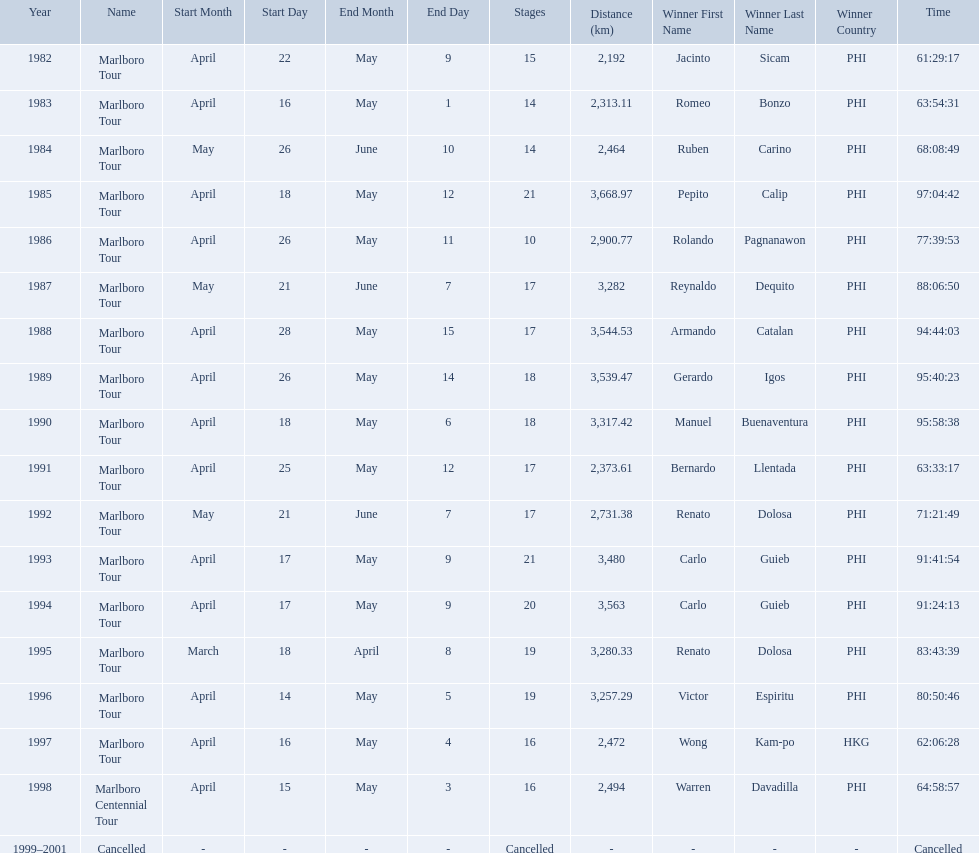What were the tour names during le tour de filipinas? Marlboro Tour, Marlboro Tour, Marlboro Tour, Marlboro Tour, Marlboro Tour, Marlboro Tour, Marlboro Tour, Marlboro Tour, Marlboro Tour, Marlboro Tour, Marlboro Tour, Marlboro Tour, Marlboro Tour, Marlboro Tour, Marlboro Tour, Marlboro Tour, Marlboro Centennial Tour, Cancelled. What were the recorded distances for each marlboro tour? 2,192 km, 2,313.11 km, 2,464 km, 3,668.97 km, 2,900.77 km, 3,282 km, 3,544.53 km, 3,539.47 km, 3,317.42 km, 2,373.61 km, 2,731.38 km, 3,480 km, 3,563 km, 3,280.33 km, 3,257.29 km, 2,472 km. And of those distances, which was the longest? 3,668.97 km. How far did the marlboro tour travel each year? 2,192 km, 2,313.11 km, 2,464 km, 3,668.97 km, 2,900.77 km, 3,282 km, 3,544.53 km, 3,539.47 km, 3,317.42 km, 2,373.61 km, 2,731.38 km, 3,480 km, 3,563 km, 3,280.33 km, 3,257.29 km, 2,472 km, 2,494 km, Cancelled. In what year did they travel the furthest? 1985. How far did they travel that year? 3,668.97 km. What race did warren davadilla compete in in 1998? Marlboro Centennial Tour. How long did it take davadilla to complete the marlboro centennial tour? 64:58:57. Who were all of the winners? Jacinto Sicam (PHI), Romeo Bonzo (PHI), Ruben Carino (PHI), Pepito Calip (PHI), Rolando Pagnanawon (PHI), Reynaldo Dequito (PHI), Armando Catalan (PHI), Gerardo Igos (PHI), Manuel Buenaventura (PHI), Bernardo Llentada (PHI), Renato Dolosa (PHI), Carlo Guieb (PHI), Carlo Guieb (PHI), Renato Dolosa (PHI), Victor Espiritu (PHI), Wong Kam-po (HKG), Warren Davadilla (PHI), Cancelled. When did they compete? 1982, 1983, 1984, 1985, 1986, 1987, 1988, 1989, 1990, 1991, 1992, 1993, 1994, 1995, 1996, 1997, 1998, 1999–2001. What were their finishing times? 61:29:17, 63:54:31, 68:08:49, 97:04:42, 77:39:53, 88:06:50, 94:44:03, 95:40:23, 95:58:38, 63:33:17, 71:21:49, 91:41:54, 91:24:13, 83:43:39, 80:50:46, 62:06:28, 64:58:57, Cancelled. Would you be able to parse every entry in this table? {'header': ['Year', 'Name', 'Start Month', 'Start Day', 'End Month', 'End Day', 'Stages', 'Distance (km)', 'Winner First Name', 'Winner Last Name', 'Winner Country', 'Time'], 'rows': [['1982', 'Marlboro Tour', 'April', '22', 'May', '9', '15', '2,192', 'Jacinto', 'Sicam', 'PHI', '61:29:17'], ['1983', 'Marlboro Tour', 'April', '16', 'May', '1', '14', '2,313.11', 'Romeo', 'Bonzo', 'PHI', '63:54:31'], ['1984', 'Marlboro Tour', 'May', '26', 'June', '10', '14', '2,464', 'Ruben', 'Carino', 'PHI', '68:08:49'], ['1985', 'Marlboro Tour', 'April', '18', 'May', '12', '21', '3,668.97', 'Pepito', 'Calip', 'PHI', '97:04:42'], ['1986', 'Marlboro Tour', 'April', '26', 'May', '11', '10', '2,900.77', 'Rolando', 'Pagnanawon', 'PHI', '77:39:53'], ['1987', 'Marlboro Tour', 'May', '21', 'June', '7', '17', '3,282', 'Reynaldo', 'Dequito', 'PHI', '88:06:50'], ['1988', 'Marlboro Tour', 'April', '28', 'May', '15', '17', '3,544.53', 'Armando', 'Catalan', 'PHI', '94:44:03'], ['1989', 'Marlboro Tour', 'April', '26', 'May', '14', '18', '3,539.47', 'Gerardo', 'Igos', 'PHI', '95:40:23'], ['1990', 'Marlboro Tour', 'April', '18', 'May', '6', '18', '3,317.42', 'Manuel', 'Buenaventura', 'PHI', '95:58:38'], ['1991', 'Marlboro Tour', 'April', '25', 'May', '12', '17', '2,373.61', 'Bernardo', 'Llentada', 'PHI', '63:33:17'], ['1992', 'Marlboro Tour', 'May', '21', 'June', '7', '17', '2,731.38', 'Renato', 'Dolosa', 'PHI', '71:21:49'], ['1993', 'Marlboro Tour', 'April', '17', 'May', '9', '21', '3,480', 'Carlo', 'Guieb', 'PHI', '91:41:54'], ['1994', 'Marlboro Tour', 'April', '17', 'May', '9', '20', '3,563', 'Carlo', 'Guieb', 'PHI', '91:24:13'], ['1995', 'Marlboro Tour', 'March', '18', 'April', '8', '19', '3,280.33', 'Renato', 'Dolosa', 'PHI', '83:43:39'], ['1996', 'Marlboro Tour', 'April', '14', 'May', '5', '19', '3,257.29', 'Victor', 'Espiritu', 'PHI', '80:50:46'], ['1997', 'Marlboro Tour', 'April', '16', 'May', '4', '16', '2,472', 'Wong', 'Kam-po', 'HKG', '62:06:28'], ['1998', 'Marlboro Centennial Tour', 'April', '15', 'May', '3', '16', '2,494', 'Warren', 'Davadilla', 'PHI', '64:58:57'], ['1999–2001', 'Cancelled', '-', '-', '-', '-', 'Cancelled', '-', '-', '-', '-', 'Cancelled']]} And who won during 1998? Warren Davadilla (PHI). What was his time? 64:58:57. 